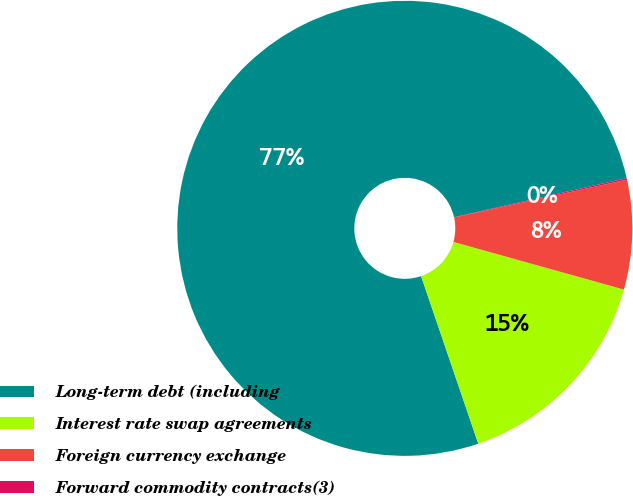Convert chart. <chart><loc_0><loc_0><loc_500><loc_500><pie_chart><fcel>Long-term debt (including<fcel>Interest rate swap agreements<fcel>Foreign currency exchange<fcel>Forward commodity contracts(3)<nl><fcel>76.69%<fcel>15.43%<fcel>7.77%<fcel>0.11%<nl></chart> 